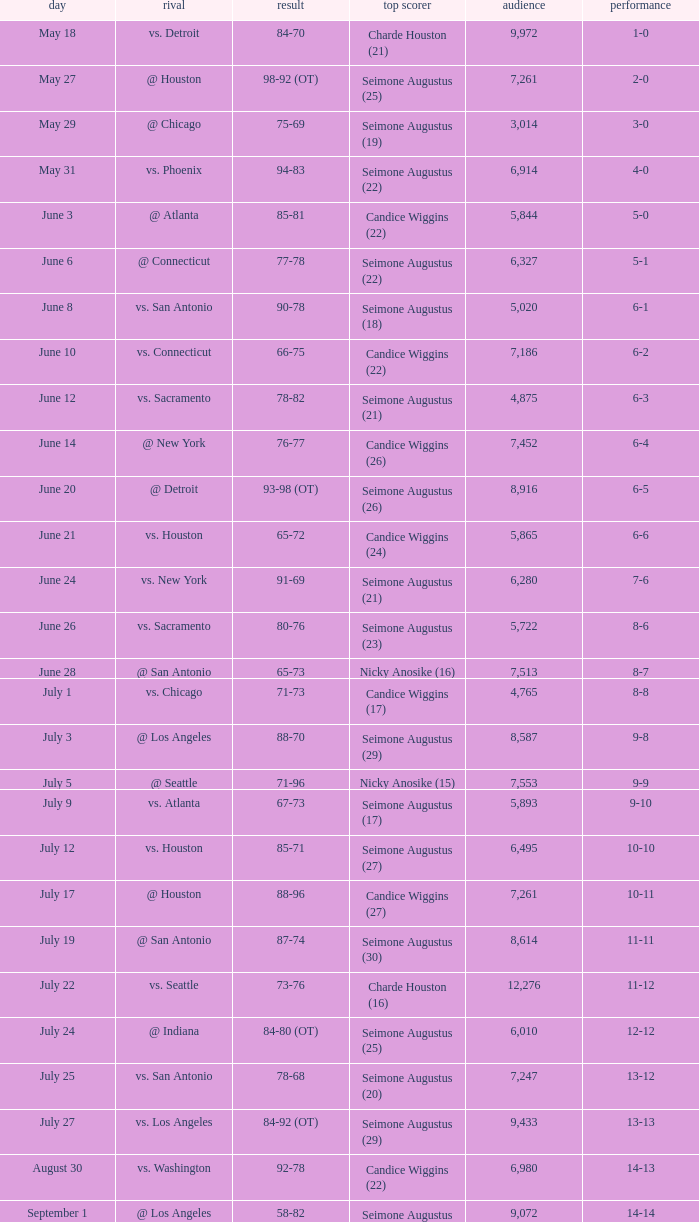Which Score has an Opponent of @ houston, and a Record of 2-0? 98-92 (OT). 